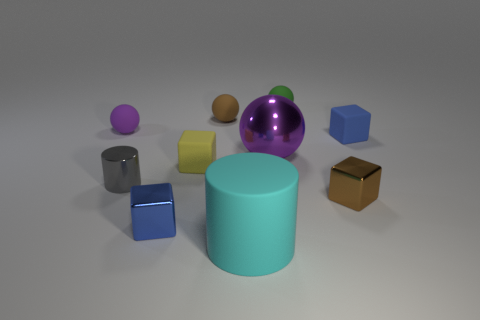How many blue cubes must be subtracted to get 1 blue cubes? 1 Subtract 1 blocks. How many blocks are left? 3 Subtract all red cylinders. Subtract all gray spheres. How many cylinders are left? 2 Subtract all cylinders. How many objects are left? 8 Subtract 0 green cylinders. How many objects are left? 10 Subtract all small gray things. Subtract all brown blocks. How many objects are left? 8 Add 2 brown blocks. How many brown blocks are left? 3 Add 7 large purple spheres. How many large purple spheres exist? 8 